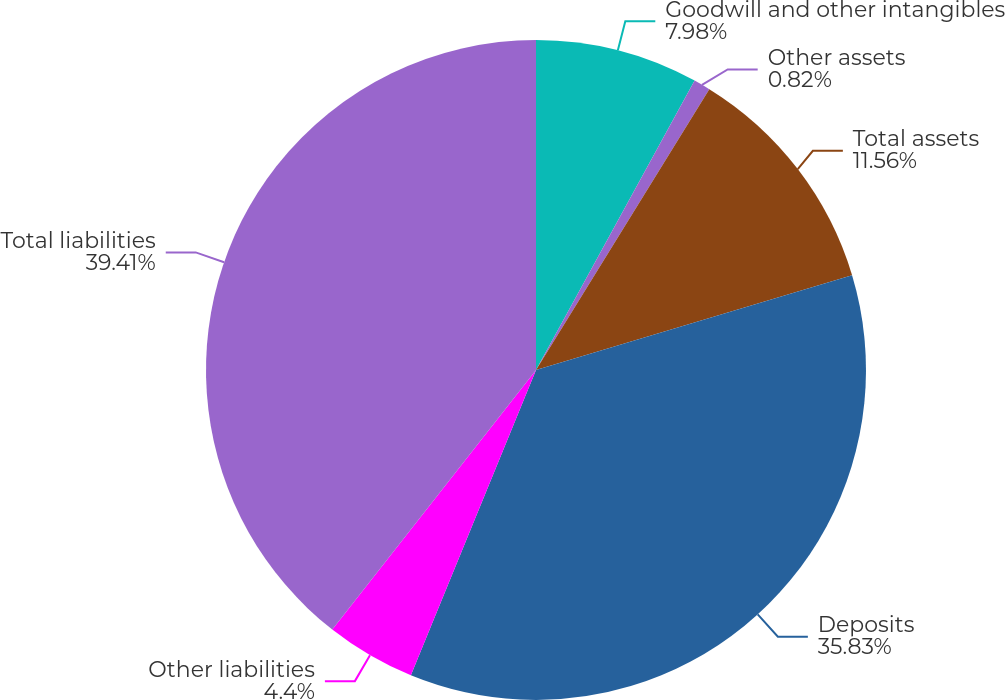Convert chart to OTSL. <chart><loc_0><loc_0><loc_500><loc_500><pie_chart><fcel>Goodwill and other intangibles<fcel>Other assets<fcel>Total assets<fcel>Deposits<fcel>Other liabilities<fcel>Total liabilities<nl><fcel>7.98%<fcel>0.82%<fcel>11.56%<fcel>35.83%<fcel>4.4%<fcel>39.41%<nl></chart> 